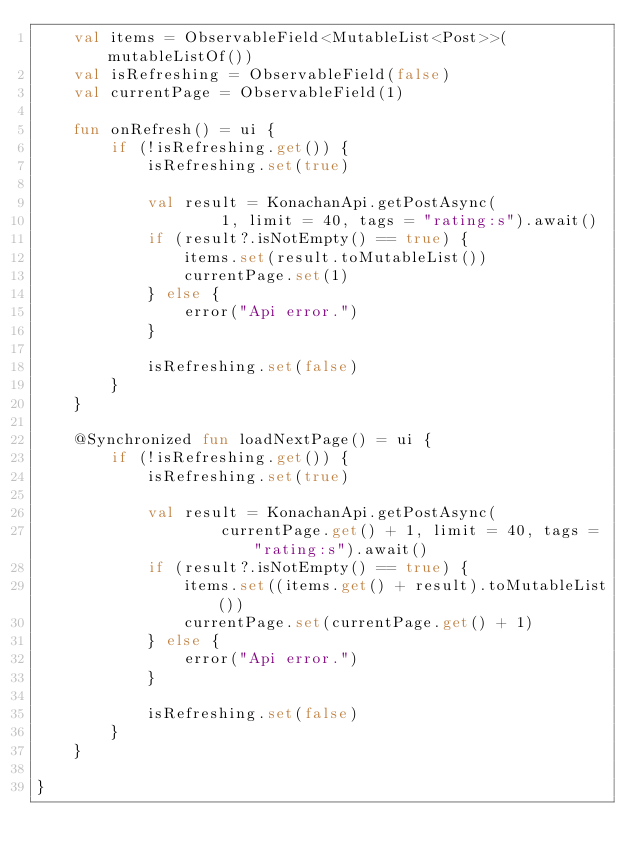Convert code to text. <code><loc_0><loc_0><loc_500><loc_500><_Kotlin_>	val items = ObservableField<MutableList<Post>>(mutableListOf())
	val isRefreshing = ObservableField(false)
	val currentPage = ObservableField(1)

	fun onRefresh() = ui {
		if (!isRefreshing.get()) {
			isRefreshing.set(true)

			val result = KonachanApi.getPostAsync(
					1, limit = 40, tags = "rating:s").await()
			if (result?.isNotEmpty() == true) {
				items.set(result.toMutableList())
				currentPage.set(1)
			} else {
				error("Api error.")
			}

			isRefreshing.set(false)
		}
	}

	@Synchronized fun loadNextPage() = ui {
		if (!isRefreshing.get()) {
			isRefreshing.set(true)

			val result = KonachanApi.getPostAsync(
					currentPage.get() + 1, limit = 40, tags = "rating:s").await()
			if (result?.isNotEmpty() == true) {
				items.set((items.get() + result).toMutableList())
				currentPage.set(currentPage.get() + 1)
			} else {
				error("Api error.")
			}

			isRefreshing.set(false)
		}
	}

}</code> 